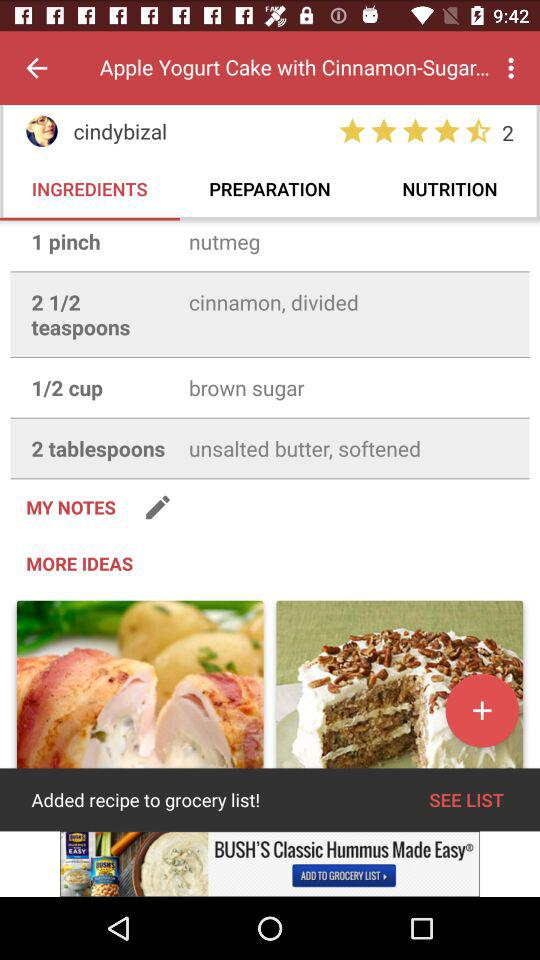Which tab has been selected? The tab that has been selected is "INGREDIENTS". 